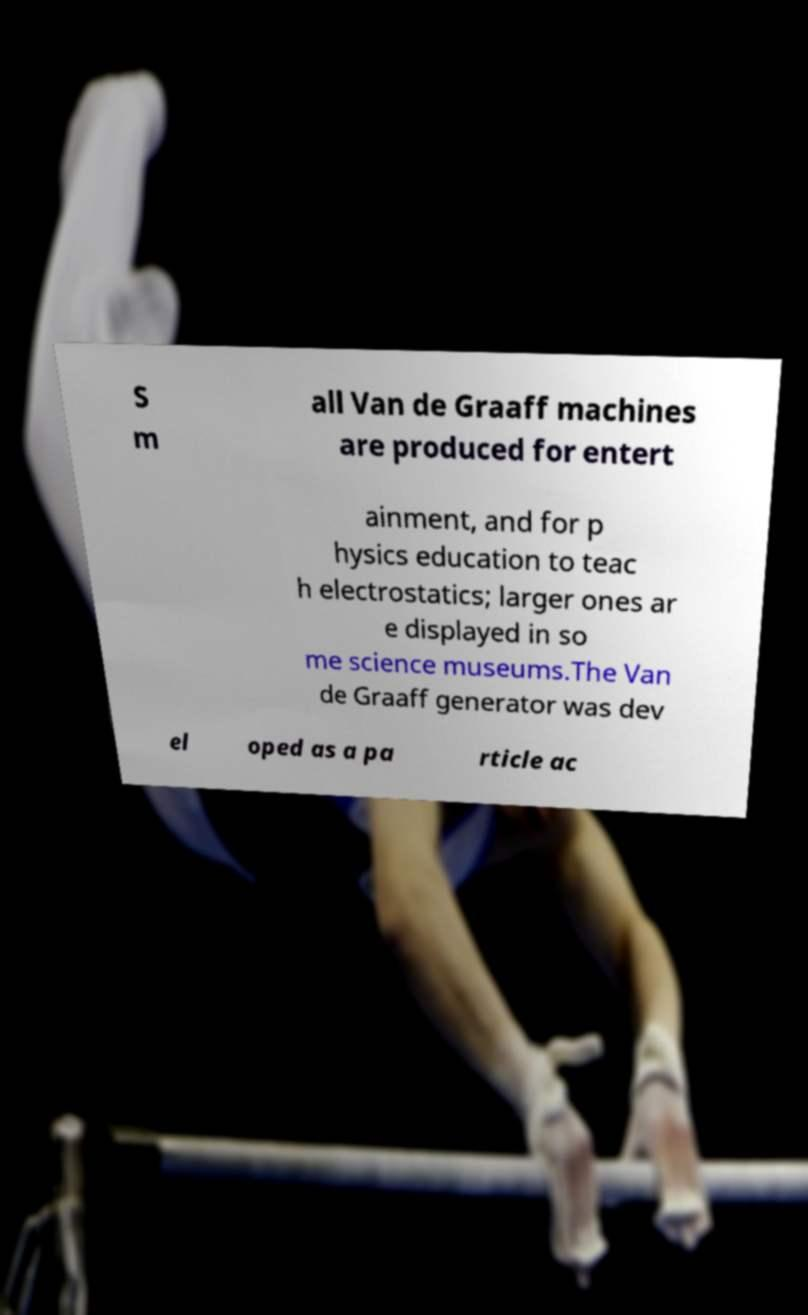Please read and relay the text visible in this image. What does it say? S m all Van de Graaff machines are produced for entert ainment, and for p hysics education to teac h electrostatics; larger ones ar e displayed in so me science museums.The Van de Graaff generator was dev el oped as a pa rticle ac 